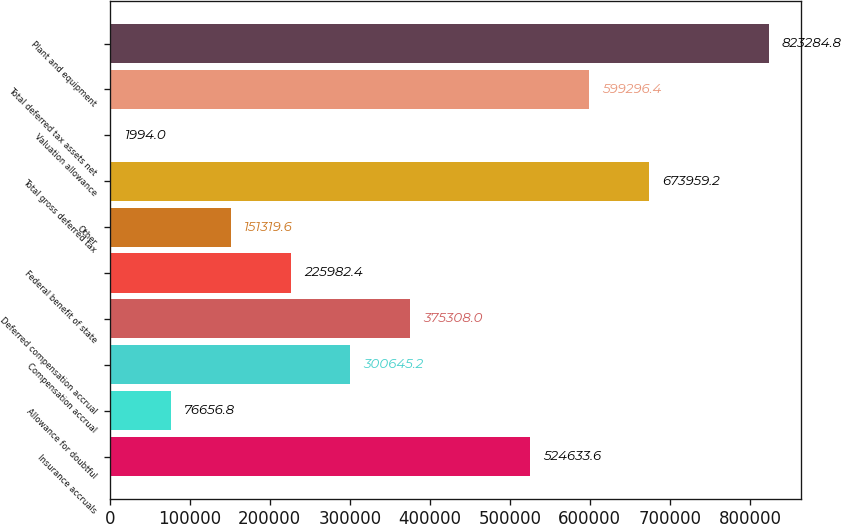Convert chart. <chart><loc_0><loc_0><loc_500><loc_500><bar_chart><fcel>Insurance accruals<fcel>Allowance for doubtful<fcel>Compensation accrual<fcel>Deferred compensation accrual<fcel>Federal benefit of state<fcel>Other<fcel>Total gross deferred tax<fcel>Valuation allowance<fcel>Total deferred tax assets net<fcel>Plant and equipment<nl><fcel>524634<fcel>76656.8<fcel>300645<fcel>375308<fcel>225982<fcel>151320<fcel>673959<fcel>1994<fcel>599296<fcel>823285<nl></chart> 